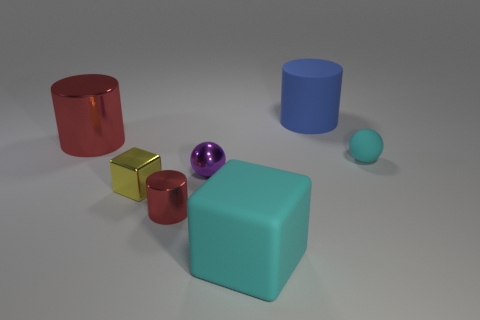What number of other objects are there of the same shape as the large red metal object? 2 